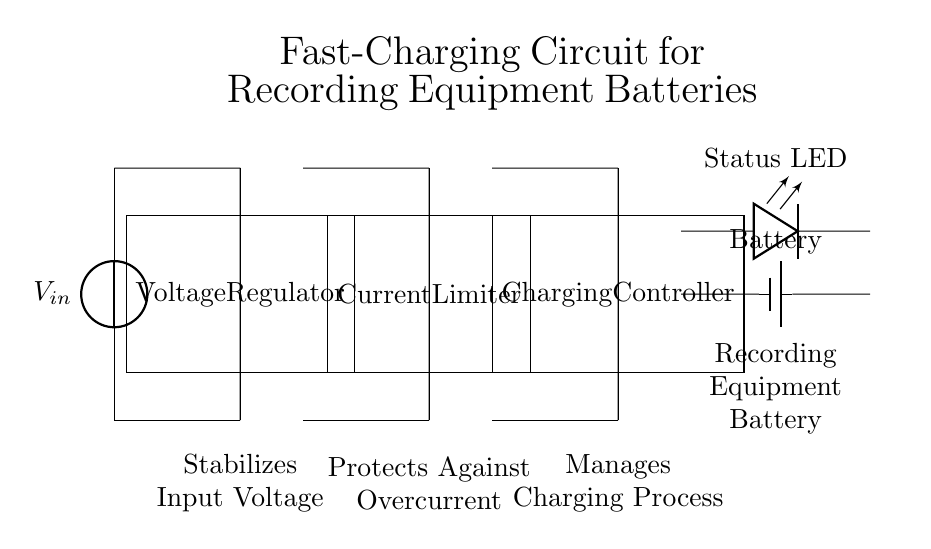What type of component is represented as the first block? The first block is a voltage regulator, which stabilizes the input voltage before it is sent to the next components.
Answer: Voltage regulator What does the current limiter protect against? The current limiter protects against overcurrent, which can damage the components by allowing too much current to flow through.
Answer: Overcurrent What is the purpose of the charging controller? The charging controller manages the charging process of the battery, ensuring that it receives the correct charge based on its state.
Answer: Manages charging process How is the battery indicated in the circuit? The battery is indicated with a symbol labeled "Battery" and is represented as a rectangular shape with terminals.
Answer: Battery Which component shows the operational status of the circuit? The operational status is shown by the LED indicator, which lights up to indicate the charging status.
Answer: Status LED What is the input source voltage labeled as? The input source voltage is labeled as "V_in" at the top left of the circuit diagram, indicating the voltage supplied to the circuit.
Answer: V_in Which component in the circuit diagram is responsible for converting AC voltage to DC voltage? The voltage regulator is responsible for converting and stabilizing the incoming AC voltage to a usable DC voltage.
Answer: Voltage regulator 